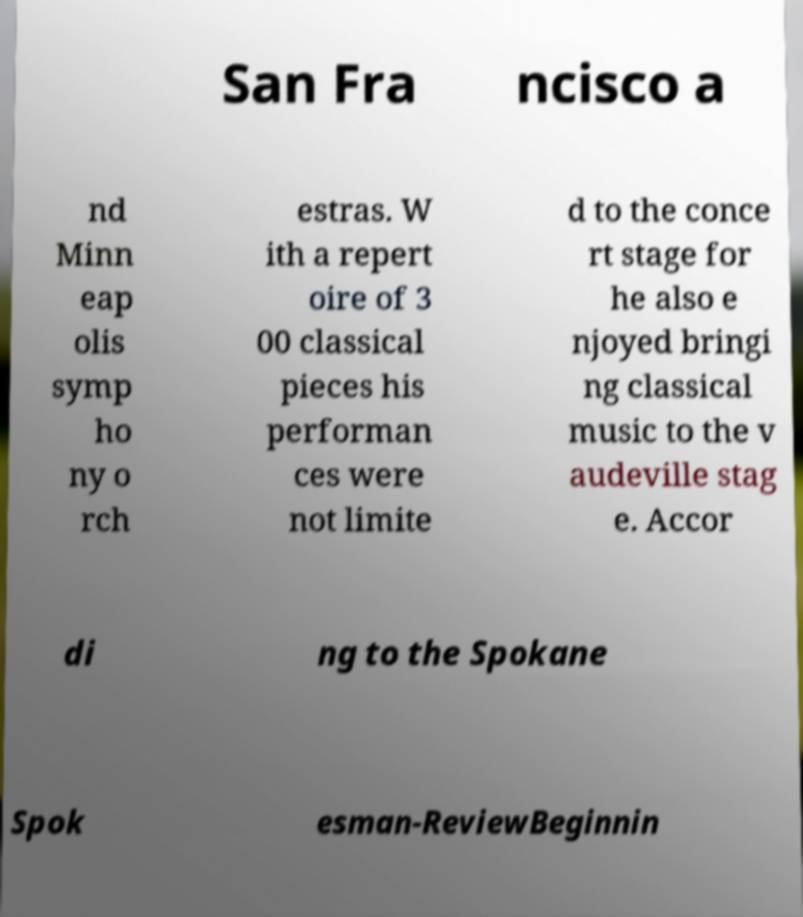Could you extract and type out the text from this image? San Fra ncisco a nd Minn eap olis symp ho ny o rch estras. W ith a repert oire of 3 00 classical pieces his performan ces were not limite d to the conce rt stage for he also e njoyed bringi ng classical music to the v audeville stag e. Accor di ng to the Spokane Spok esman-ReviewBeginnin 